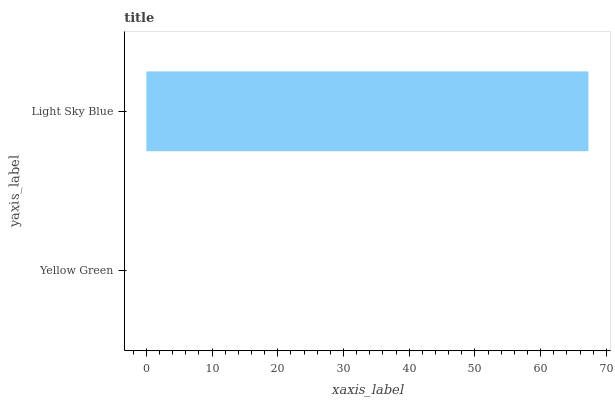Is Yellow Green the minimum?
Answer yes or no. Yes. Is Light Sky Blue the maximum?
Answer yes or no. Yes. Is Light Sky Blue the minimum?
Answer yes or no. No. Is Light Sky Blue greater than Yellow Green?
Answer yes or no. Yes. Is Yellow Green less than Light Sky Blue?
Answer yes or no. Yes. Is Yellow Green greater than Light Sky Blue?
Answer yes or no. No. Is Light Sky Blue less than Yellow Green?
Answer yes or no. No. Is Light Sky Blue the high median?
Answer yes or no. Yes. Is Yellow Green the low median?
Answer yes or no. Yes. Is Yellow Green the high median?
Answer yes or no. No. Is Light Sky Blue the low median?
Answer yes or no. No. 